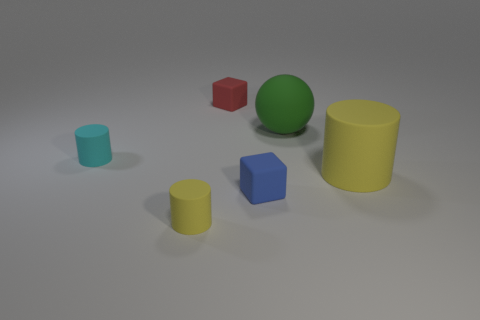If you had to guess, which object seems to be the largest based on this perspective? From this perspective, the large yellow cylinder on the right appears to be the largest object given its size relative to the other objects and its positioning within the scene.  And which object looks the smallest? The small blue cube appears to be the smallest object in relation to the others, both in terms of its dimensions and its visual impact in the scene. 